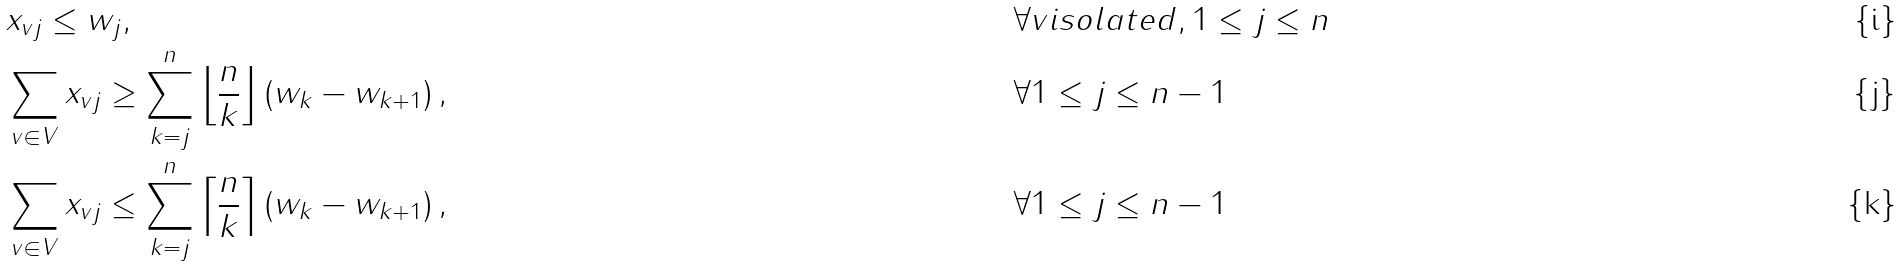Convert formula to latex. <formula><loc_0><loc_0><loc_500><loc_500>& x _ { v j } \leq w _ { j } , & & \forall v i s o l a t e d , 1 \leq j \leq n \\ & \sum _ { v \in V } x _ { v j } \geq \sum _ { k = j } ^ { n } \left \lfloor \frac { n } { k } \right \rfloor \left ( w _ { k } - w _ { k + 1 } \right ) , & & \forall 1 \leq j \leq n - 1 \\ & \sum _ { v \in V } x _ { v j } \leq \sum _ { k = j } ^ { n } \left \lceil \frac { n } { k } \right \rceil \left ( w _ { k } - w _ { k + 1 } \right ) , & & \forall 1 \leq j \leq n - 1</formula> 